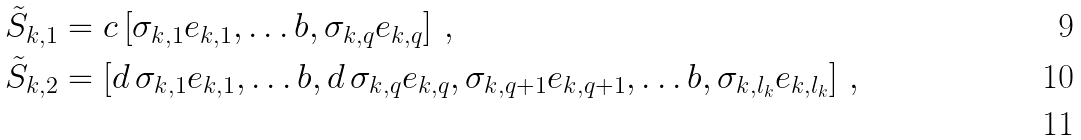<formula> <loc_0><loc_0><loc_500><loc_500>& \tilde { S } _ { k , 1 } = c \left [ \sigma _ { k , 1 } e _ { k , 1 } , \dots b , \sigma _ { k , q } e _ { k , q } \right ] \, , \\ & \tilde { S } _ { k , 2 } = \left [ d \, \sigma _ { k , 1 } e _ { k , 1 } , \dots b , d \, \sigma _ { k , q } e _ { k , q } , \sigma _ { k , q + 1 } e _ { k , q + 1 } , \dots b , \sigma _ { k , l _ { k } } e _ { k , l _ { k } } \right ] \, , \\</formula> 